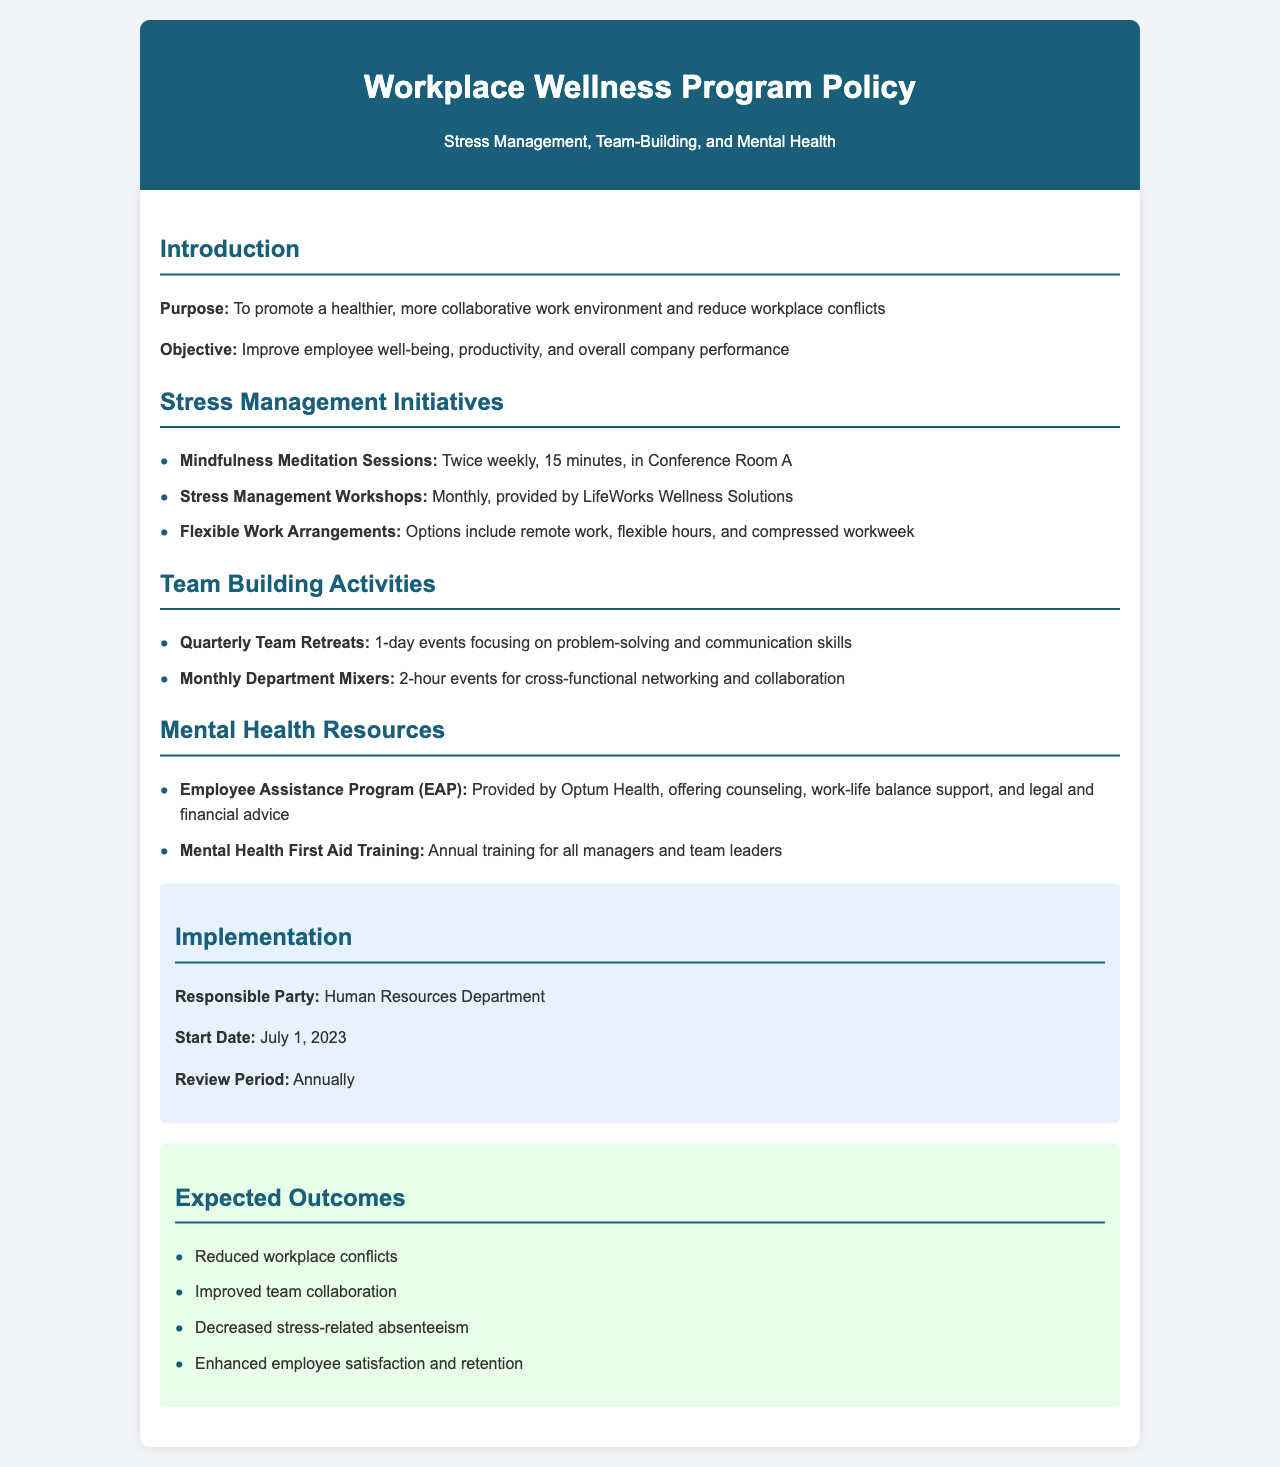What is the purpose of the policy? The purpose is to promote a healthier, more collaborative work environment and reduce workplace conflicts.
Answer: promote a healthier, more collaborative work environment and reduce workplace conflicts How often are mindfulness meditation sessions held? Mindfulness meditation sessions are scheduled twice weekly as stated in the initiatives section.
Answer: twice weekly What company provides the Employee Assistance Program? The document specifies that the Employee Assistance Program is provided by Optum Health.
Answer: Optum Health What is the start date for the implementation of the program? The document indicates that the start date for the implementation is July 1, 2023.
Answer: July 1, 2023 What is one expected outcome of the program? The expected outcomes section lists several outcomes, including reduced workplace conflicts.
Answer: reduced workplace conflicts How long are the quarterly team retreats? The document mentions that the quarterly team retreats are 1-day events.
Answer: 1-day Who is responsible for the implementation of the policy? The policy states that the Human Resources Department is responsible for implementation.
Answer: Human Resources Department What type of training is provided annually for all managers and team leaders? According to the document, the type of training provided annually is Mental Health First Aid Training.
Answer: Mental Health First Aid Training 